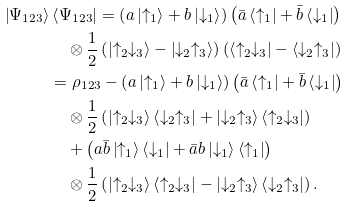Convert formula to latex. <formula><loc_0><loc_0><loc_500><loc_500>\left | \Psi _ { 1 2 3 } \right \rangle & \left \langle \Psi _ { 1 2 3 } \right | = \left ( a \left | \uparrow _ { 1 } \right \rangle + b \left | \downarrow _ { 1 } \right \rangle \right ) \left ( \bar { a } \left \langle \uparrow _ { 1 } \right | + \bar { b } \left \langle \downarrow _ { 1 } \right | \right ) \\ & \quad \otimes \frac { 1 } { 2 } \left ( \left | \uparrow _ { 2 } \downarrow _ { 3 } \right \rangle - \left | \downarrow _ { 2 } \uparrow _ { 3 } \right \rangle \right ) \left ( \left \langle \uparrow _ { 2 } \downarrow _ { 3 } \right | - \left \langle \downarrow _ { 2 } \uparrow _ { 3 } \right | \right ) \\ & = \rho _ { 1 2 3 } - \left ( a \left | \uparrow _ { 1 } \right \rangle + b \left | \downarrow _ { 1 } \right \rangle \right ) \left ( \bar { a } \left \langle \uparrow _ { 1 } \right | + \bar { b } \left \langle \downarrow _ { 1 } \right | \right ) \\ & \quad \otimes \frac { 1 } { 2 } \left ( \left | \uparrow _ { 2 } \downarrow _ { 3 } \right \rangle \left \langle \downarrow _ { 2 } \uparrow _ { 3 } \right | + \left | \downarrow _ { 2 } \uparrow _ { 3 } \right \rangle \left \langle \uparrow _ { 2 } \downarrow _ { 3 } \right | \right ) \\ & \quad + \left ( a \bar { b } \left | \uparrow _ { 1 } \right \rangle \left \langle \downarrow _ { 1 } \right | + \bar { a } b \left | \downarrow _ { 1 } \right \rangle \left \langle \uparrow _ { 1 } \right | \right ) \\ & \quad \otimes \frac { 1 } { 2 } \left ( \left | \uparrow _ { 2 } \downarrow _ { 3 } \right \rangle \left \langle \uparrow _ { 2 } \downarrow _ { 3 } \right | - \left | \downarrow _ { 2 } \uparrow _ { 3 } \right \rangle \left \langle \downarrow _ { 2 } \uparrow _ { 3 } \right | \right ) .</formula> 